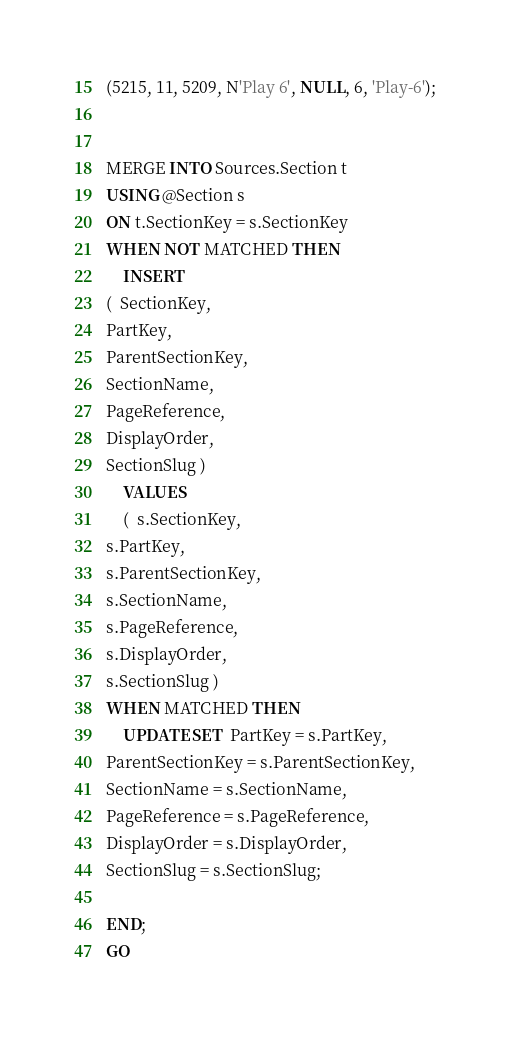Convert code to text. <code><loc_0><loc_0><loc_500><loc_500><_SQL_>(5215, 11, 5209, N'Play 6', NULL, 6, 'Play-6');


MERGE INTO Sources.Section t
USING @Section s
ON t.SectionKey = s.SectionKey
WHEN NOT MATCHED THEN
    INSERT
(  SectionKey,
PartKey,
ParentSectionKey,
SectionName,
PageReference,
DisplayOrder,
SectionSlug )
    VALUES
    (  s.SectionKey,
s.PartKey,
s.ParentSectionKey,
s.SectionName,
s.PageReference,
s.DisplayOrder,
s.SectionSlug )
WHEN MATCHED THEN
    UPDATE SET  PartKey = s.PartKey,
ParentSectionKey = s.ParentSectionKey,
SectionName = s.SectionName,
PageReference = s.PageReference,
DisplayOrder = s.DisplayOrder,
SectionSlug = s.SectionSlug;

END;
GO
</code> 